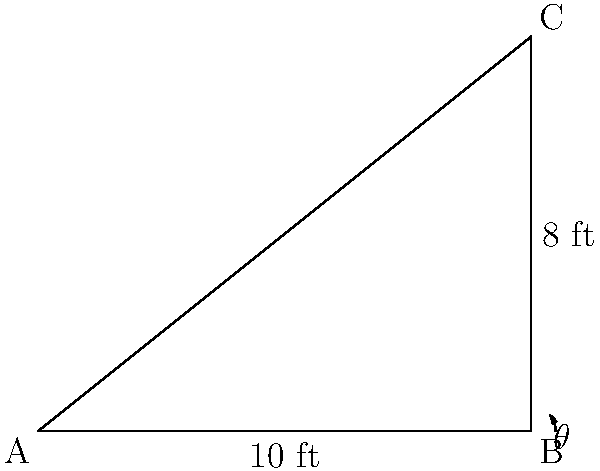A retired couple wants to install a slanted bookshelf to maximize space in their newly downsized home. The shelf will be attached to the wall and floor, forming a right triangle. If the wall height is 8 feet and the floor length is 10 feet, what is the angle of inclination ($\theta$) between the shelf and the floor? To find the angle of inclination, we can use trigonometry:

1) The shelf forms a right triangle with the wall and floor.
2) We know the opposite side (wall height) = 8 feet
3) We know the adjacent side (floor length) = 10 feet
4) To find the angle, we can use the tangent function:

   $\tan(\theta) = \frac{\text{opposite}}{\text{adjacent}} = \frac{8}{10} = 0.8$

5) To get the angle, we need to use the inverse tangent (arctan or $\tan^{-1}$):

   $\theta = \tan^{-1}(0.8)$

6) Using a calculator or trigonometric tables:

   $\theta \approx 38.66$ degrees

Therefore, the angle of inclination between the shelf and the floor is approximately 38.66 degrees.
Answer: $38.66°$ 